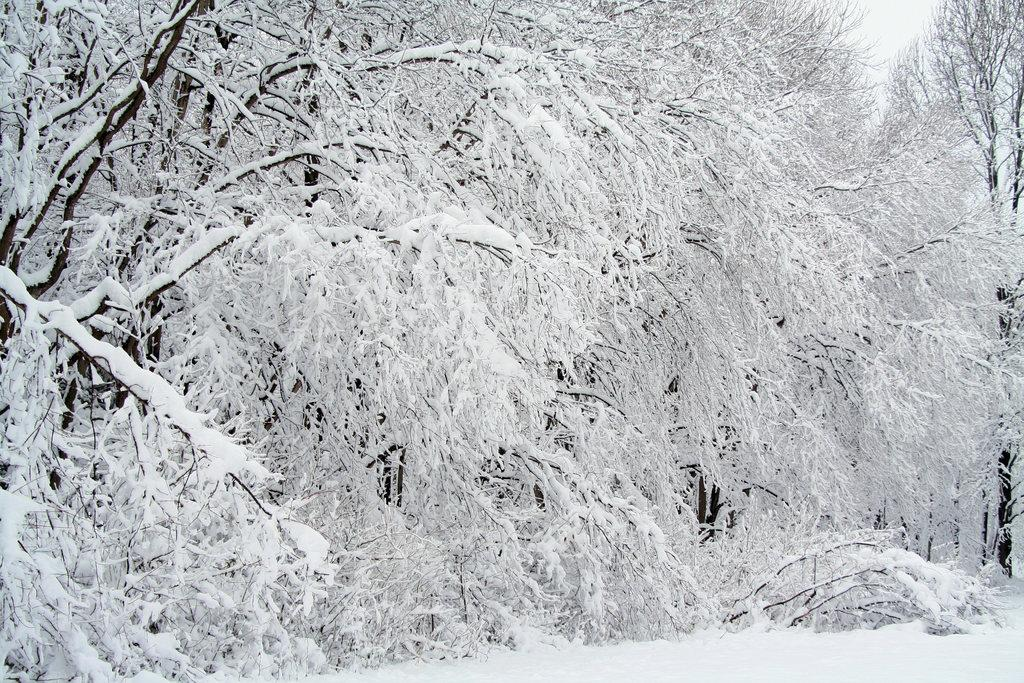What type of weather is depicted in the image? The image shows snow on the trees and at the bottom side of the image. Can you describe the condition of the trees in the image? The trees in the image have snow on them. Where is the map located in the image? There is no map present in the image. What type of toys can be seen in the snow in the image? There are no toys present in the image. 